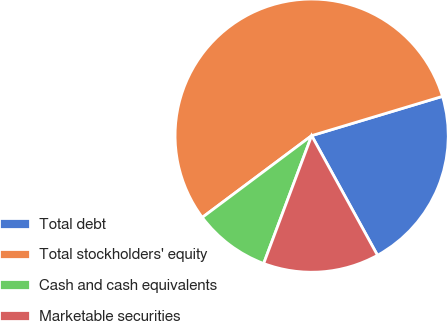<chart> <loc_0><loc_0><loc_500><loc_500><pie_chart><fcel>Total debt<fcel>Total stockholders' equity<fcel>Cash and cash equivalents<fcel>Marketable securities<nl><fcel>21.64%<fcel>55.58%<fcel>9.07%<fcel>13.72%<nl></chart> 